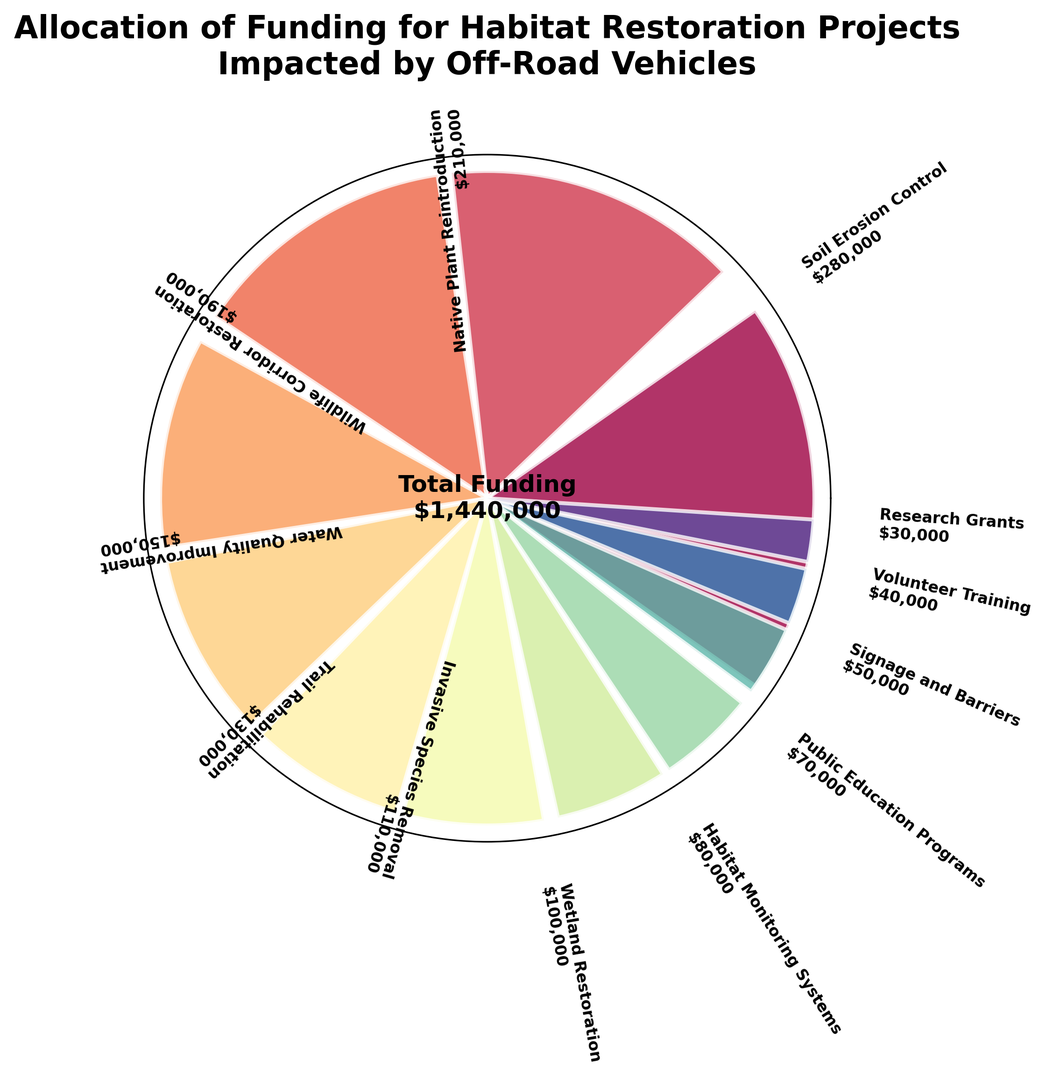Which project received the most funding? The largest segment by visual size represents the project with the highest funding allocation. The 'Soil Erosion Control' segment is visually the largest on the chart.
Answer: Soil Erosion Control How much funding was allocated to Native Plant Reintroduction compared to Invasive Species Removal? Native Plant Reintroduction ($210,000) minus Invasive Species Removal ($110,000) gives the difference.
Answer: $100,000 What is the total funding allocated to Wildlife Corridor Restoration and Water Quality Improvement combined? Sum the funding for Wildlife Corridor Restoration ($190,000) and Water Quality Improvement ($150,000).
Answer: $340,000 Which project has received the least amount of funding? The smallest segment by visual size represents the project with the lowest funding allocation. The 'Research Grants' segment is the smallest on the chart.
Answer: Research Grants Is Trail Rehabilitation funded less than Habitat Monitoring Systems? Compare the size of the segments. Trail Rehabilitation ($130,000) is larger than Habitat Monitoring Systems ($80,000).
Answer: No Which projects received more than $200,000 in funding? Identify segments that visually appear larger than $200,000. Only the 'Soil Erosion Control' and 'Native Plant Reintroduction' segments qualify.
Answer: Soil Erosion Control, Native Plant Reintroduction What is the difference in funding between Public Education Programs and Signage and Barriers? Public Education Programs ($70,000) minus Signage and Barriers ($50,000) gives the difference.
Answer: $20,000 How does the funding for Wetland Restoration compare to Water Quality Improvement? Compare the lengths of the segments. Wetland Restoration ($100,000) is less than Water Quality Improvement ($150,000).
Answer: Less Which project received $50,000 in funding? Verify the segments labeled with funding amounts. Signage and Barriers received $50,000.
Answer: Signage and Barriers If we sum the funding for Trail Rehabilitation, Volunteer Training, and Research Grants, what would the total be? Sum the funding for Trail Rehabilitation ($130,000), Volunteer Training ($40,000), and Research Grants ($30,000).
Answer: $200,000 